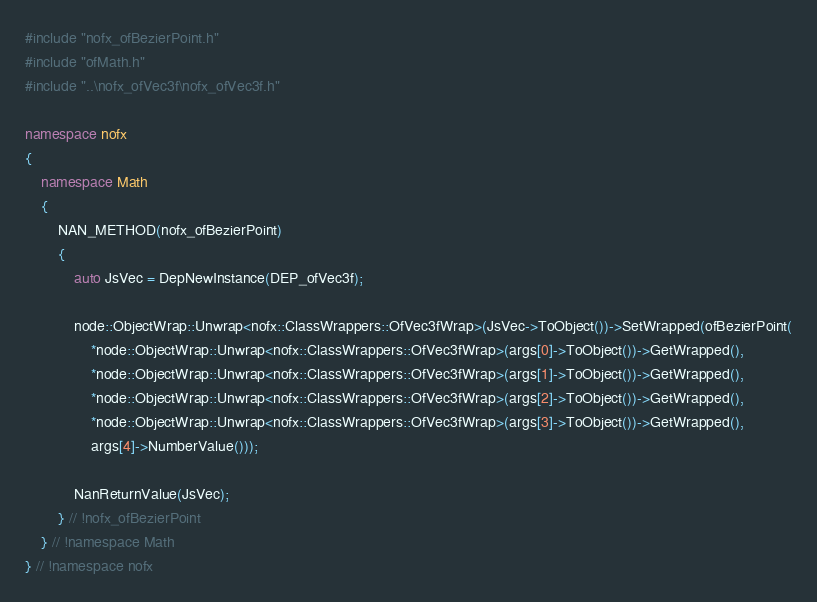Convert code to text. <code><loc_0><loc_0><loc_500><loc_500><_C++_>#include "nofx_ofBezierPoint.h"
#include "ofMath.h"
#include "..\nofx_ofVec3f\nofx_ofVec3f.h"

namespace nofx
{
    namespace Math
    {
        NAN_METHOD(nofx_ofBezierPoint)
        {
			auto JsVec = DepNewInstance(DEP_ofVec3f);
			
			node::ObjectWrap::Unwrap<nofx::ClassWrappers::OfVec3fWrap>(JsVec->ToObject())->SetWrapped(ofBezierPoint(
				*node::ObjectWrap::Unwrap<nofx::ClassWrappers::OfVec3fWrap>(args[0]->ToObject())->GetWrapped(),
				*node::ObjectWrap::Unwrap<nofx::ClassWrappers::OfVec3fWrap>(args[1]->ToObject())->GetWrapped(),
				*node::ObjectWrap::Unwrap<nofx::ClassWrappers::OfVec3fWrap>(args[2]->ToObject())->GetWrapped(),
				*node::ObjectWrap::Unwrap<nofx::ClassWrappers::OfVec3fWrap>(args[3]->ToObject())->GetWrapped(),
				args[4]->NumberValue()));
			
			NanReturnValue(JsVec);
        } // !nofx_ofBezierPoint
    } // !namespace Math
} // !namespace nofx</code> 